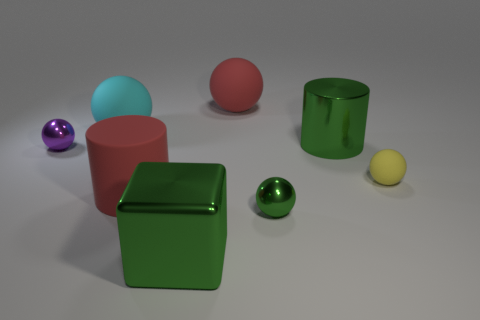Subtract 2 balls. How many balls are left? 3 Subtract all yellow spheres. How many spheres are left? 4 Subtract all small green metallic balls. How many balls are left? 4 Subtract all red spheres. Subtract all gray blocks. How many spheres are left? 4 Add 1 large green matte cylinders. How many objects exist? 9 Subtract all cubes. How many objects are left? 7 Subtract 0 blue cylinders. How many objects are left? 8 Subtract all blue metal spheres. Subtract all small yellow matte things. How many objects are left? 7 Add 5 large balls. How many large balls are left? 7 Add 4 small cyan matte cubes. How many small cyan matte cubes exist? 4 